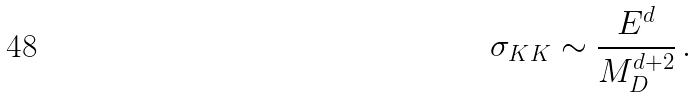Convert formula to latex. <formula><loc_0><loc_0><loc_500><loc_500>\sigma _ { K K } \sim \frac { E ^ { d } } { M ^ { d + 2 } _ { D } } \, .</formula> 